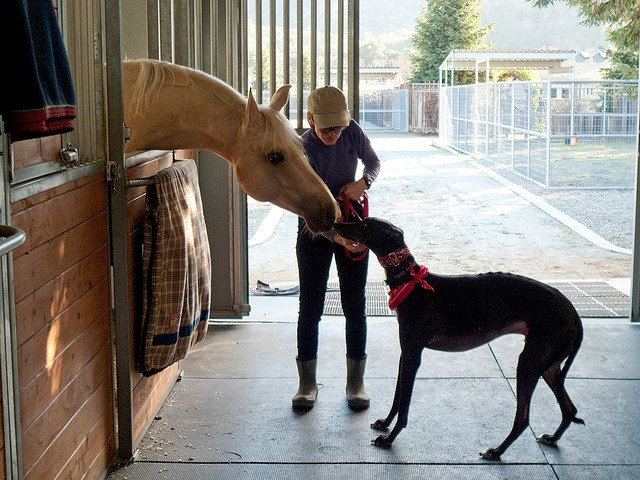Describe the objects in this image and their specific colors. I can see dog in black, maroon, lightgray, and gray tones, horse in black, maroon, and gray tones, and people in black, maroon, and gray tones in this image. 